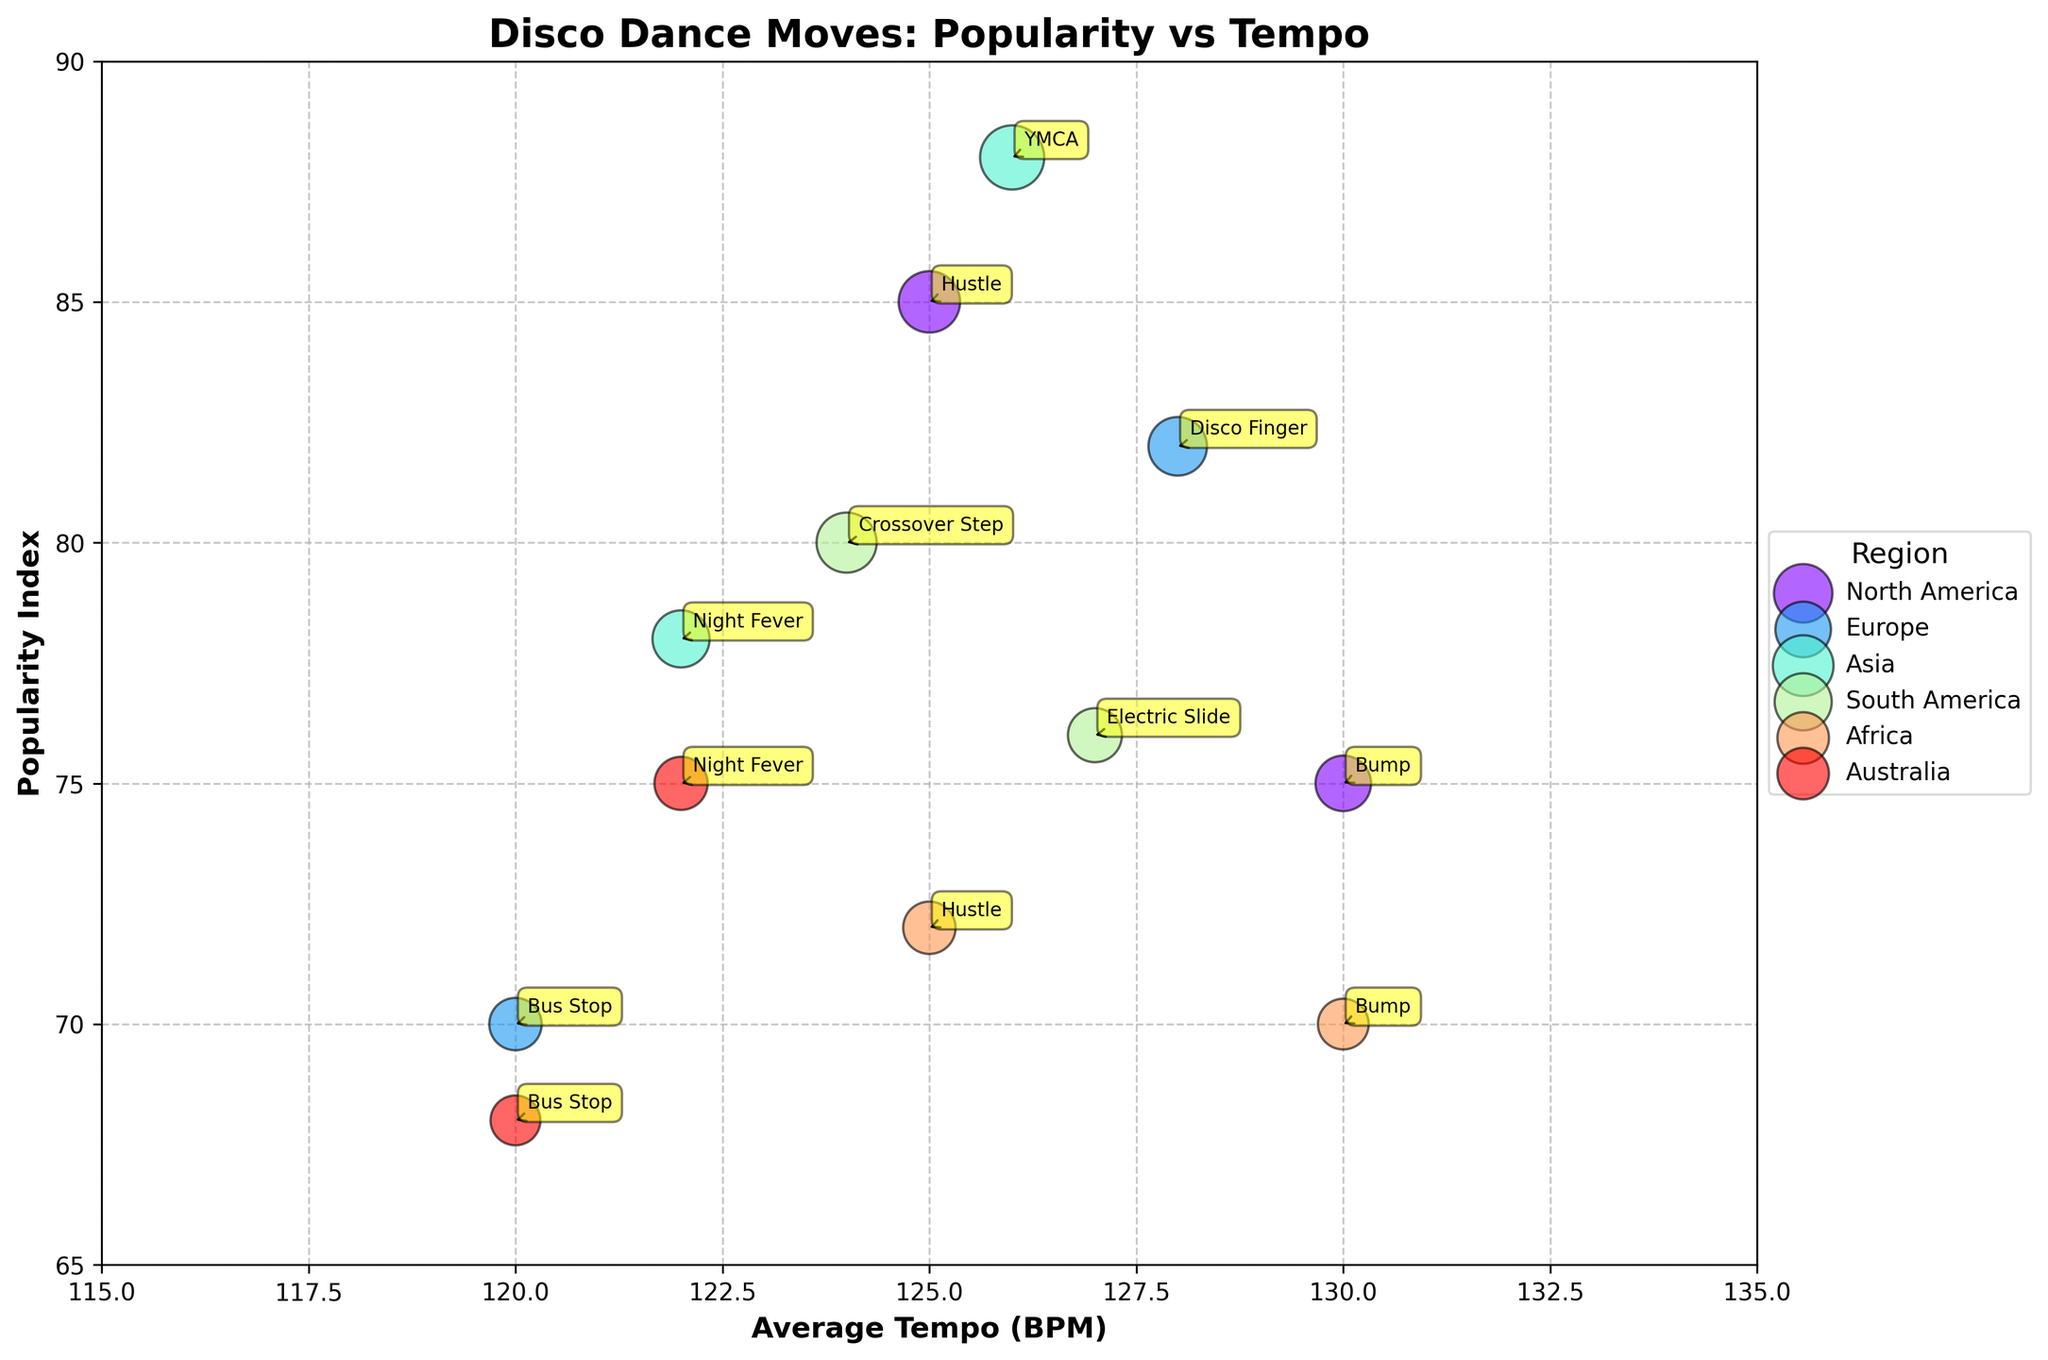How many dance moves are depicted from North America? The bubbles with dance moves from North America are labeled "Hustle" and "Bump." Counting these, we see there are 2 dance moves from North America.
Answer: 2 Which dance move has the highest Popularity Index? By observing the vertical positions of the bubbles, the "YMCA" dance move has the highest Popularity Index of 88. This is marked with a bubble located at the top of the plot.
Answer: YMCA What is the average tempo of the "Disco Finger" dance move? We locate the bubble labeled "Disco Finger" and check its horizontal position, which is 128 BPM.
Answer: 128 BPM Which region has the highest variety of dance moves depicted? Counting the distinct dance moves labeled for each region, we see North America, Europe, Asia, South America, and Africa all have 2 dance moves each, but Australia has the least with 2 types as well. Therefore, all regions except Australia have the highest variety with 2 dance moves.each
Answer: North America, Europe, Asia, South America, and Africa Between "Hustle" and "Bus Stop," which dance move has a higher average tempo? By locating the bubbles for "Hustle" and "Bus Stop" and noting their horizontal positions, "Hustle" has an average tempo of 125 BPM compared to "Bus Stop" with 120 BPM. Therefore, "Hustle" has a higher average tempo.
Answer: Hustle What is the range of Popularity Indexes among all depicted dance moves? Observing the vertical spread of the bubbles, the lowest Popularity Index is 68 (Bus Stop in Australia) and the highest is 88 (YMCA in Asia). The range is 88 - 68.
Answer: 20 Which dance move in Africa shares the same average tempo as North America's "Bump"? Both bubbles labeled "Bump" in North America and Africa should be compared for their horizontal positions. Both are at 130 BPM, so the "Bump" in Africa shares the same tempo.
Answer: Bump What is the average Popularity Index for the dance moves in Asia? The dance moves in Asia are "YMCA" with 88 and "Night Fever" with 78. Adding these indices, (88 + 78) = 166, and dividing by 2, the average Popularity Index is 83.
Answer: 83 Which dance move in South America has a higher frequency? For South America, we compare the bubbles labeled "Crossover Step" and "Electric Slide" which have sizes proportional to 210 and 170 respectively. Thus, "Crossover Step" has a higher frequency.
Answer: Crossover Step Does "Bus Stop" have the same Popularity Index in Europe and Australia? Checking bubbles labeled "Bus Stop" in Europe and Australia, both have Popularity Indexes of 70 and 68 respectively, therefore, they do not share the same Popularity Index.
Answer: No 